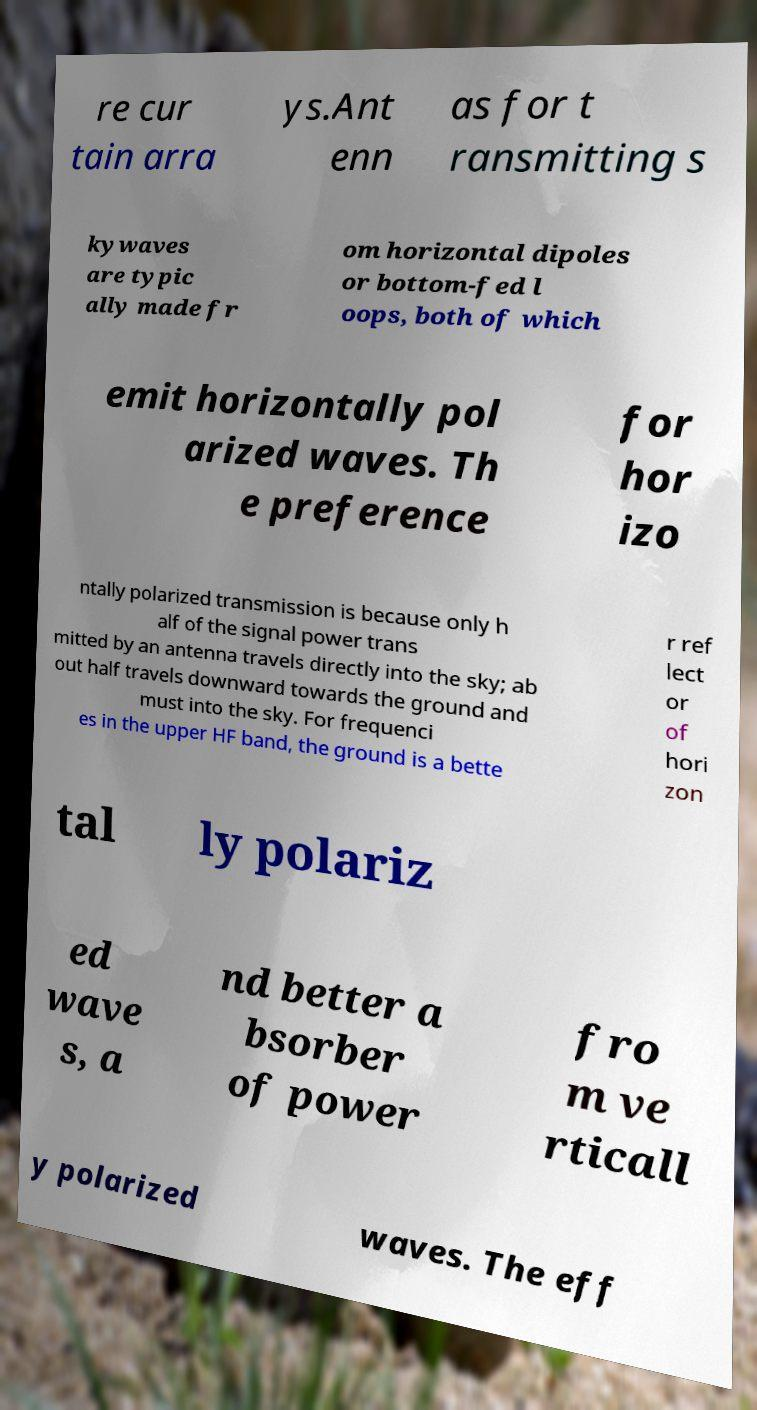Could you extract and type out the text from this image? re cur tain arra ys.Ant enn as for t ransmitting s kywaves are typic ally made fr om horizontal dipoles or bottom-fed l oops, both of which emit horizontally pol arized waves. Th e preference for hor izo ntally polarized transmission is because only h alf of the signal power trans mitted by an antenna travels directly into the sky; ab out half travels downward towards the ground and must into the sky. For frequenci es in the upper HF band, the ground is a bette r ref lect or of hori zon tal ly polariz ed wave s, a nd better a bsorber of power fro m ve rticall y polarized waves. The eff 